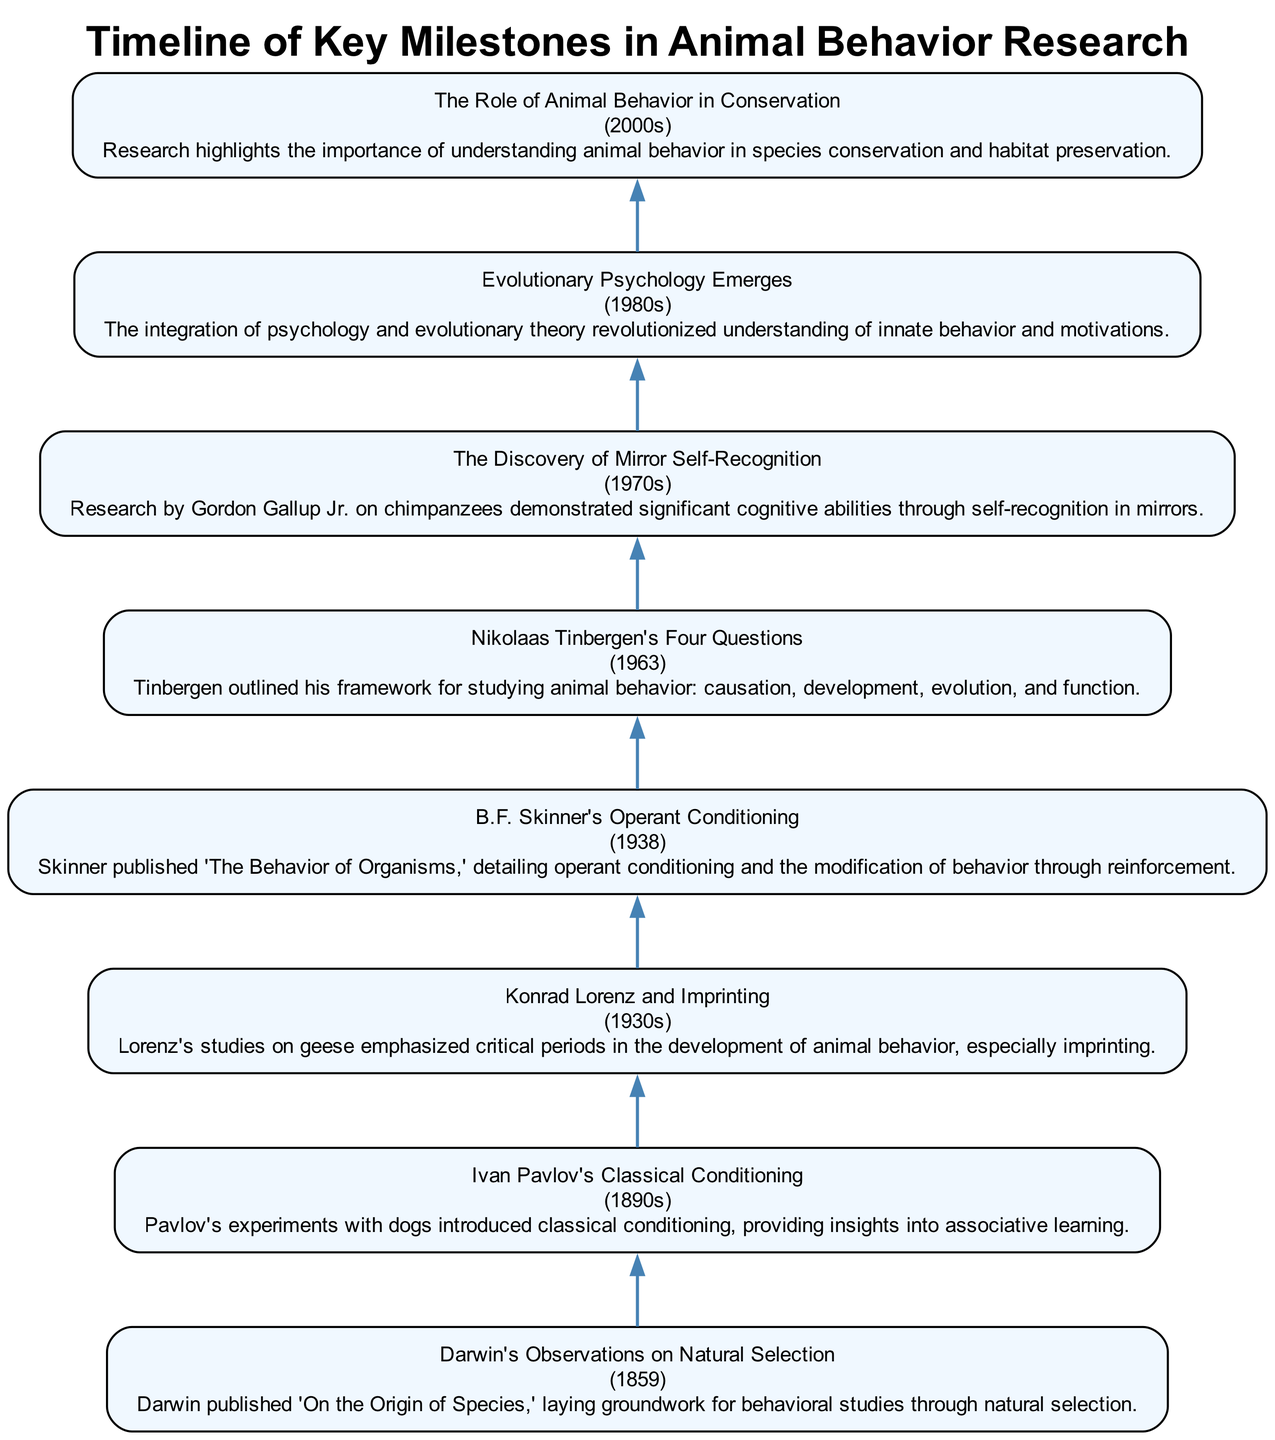What is the first milestone in animal behavior research? The first milestone in the diagram is listed as "Darwin's Observations on Natural Selection," which is at the top of the flow chart.
Answer: Darwin's Observations on Natural Selection How many key milestones are there in total? By counting the nodes in the flow chart, there are eight key milestones represented in the timeline.
Answer: 8 What year did B.F. Skinner publish 'The Behavior of Organisms'? The diagram indicates that B.F. Skinner's work was published in 1938, which can be found next to his node.
Answer: 1938 Which milestone introduced the concept of imprinting? The milestone regarding imprinting is "Konrad Lorenz and Imprinting," which is specifically mentioned in his description in the diagram.
Answer: Konrad Lorenz and Imprinting What is the significance of the 1980s in this research timeline? The 1980s is marked by the emergence of "Evolutionary Psychology," which indicates a significant development in the understanding of behavior in relation to evolution.
Answer: Evolutionary Psychology Emerges How does the milestone on mirror self-recognition connect to the understanding of cognitive abilities? This milestone, described as "The Discovery of Mirror Self-Recognition," illustrates that it provided evidence of significant cognitive abilities in animals, specifically chimpanzees, which links to the overarching theme of animal cognition.
Answer: Significant cognitive abilities What is the relationship between Ivan Pavlov's work and associative learning? Ivan Pavlov's experiments on classical conditioning introduced insights into associative learning, demonstrating how behaviors can be learned through associations between stimuli, as described in his node.
Answer: Classical conditioning What does Nikolaas Tinbergen's framework emphasize about animal behavior? Tinbergen’s framework emphasizes four key areas: causation, development, evolution, and function, which are detailed in his node to understand animal behavior comprehensively.
Answer: Causation, development, evolution, function What role does animal behavior play in conservation, according to the diagram? The diagram notes that understanding animal behavior is crucial for species conservation and habitat preservation, highlighting its importance in ecological studies.
Answer: Species conservation 